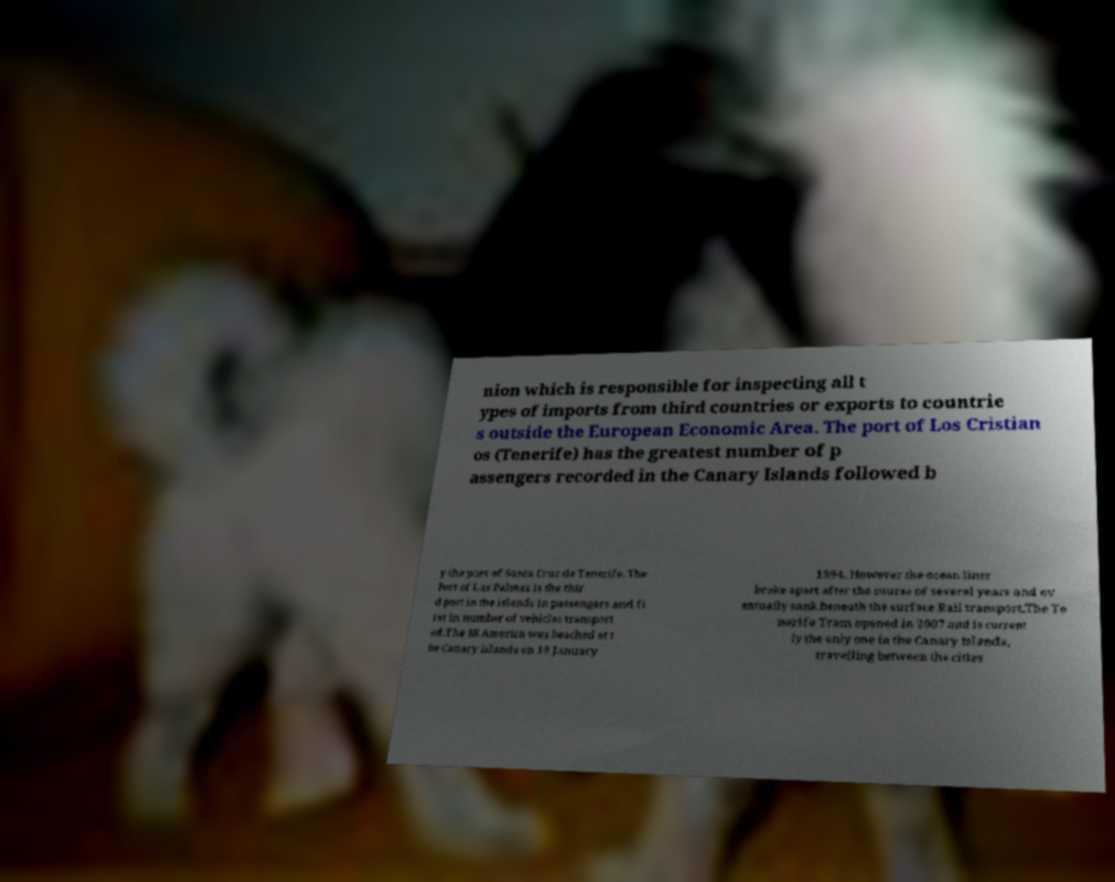I need the written content from this picture converted into text. Can you do that? nion which is responsible for inspecting all t ypes of imports from third countries or exports to countrie s outside the European Economic Area. The port of Los Cristian os (Tenerife) has the greatest number of p assengers recorded in the Canary Islands followed b y the port of Santa Cruz de Tenerife. The Port of Las Palmas is the thir d port in the islands in passengers and fi rst in number of vehicles transport ed.The SS America was beached at t he Canary islands on 18 January 1994. However the ocean liner broke apart after the course of several years and ev entually sank beneath the surface.Rail transport.The Te nerife Tram opened in 2007 and is current ly the only one in the Canary Islands, travelling between the cities 